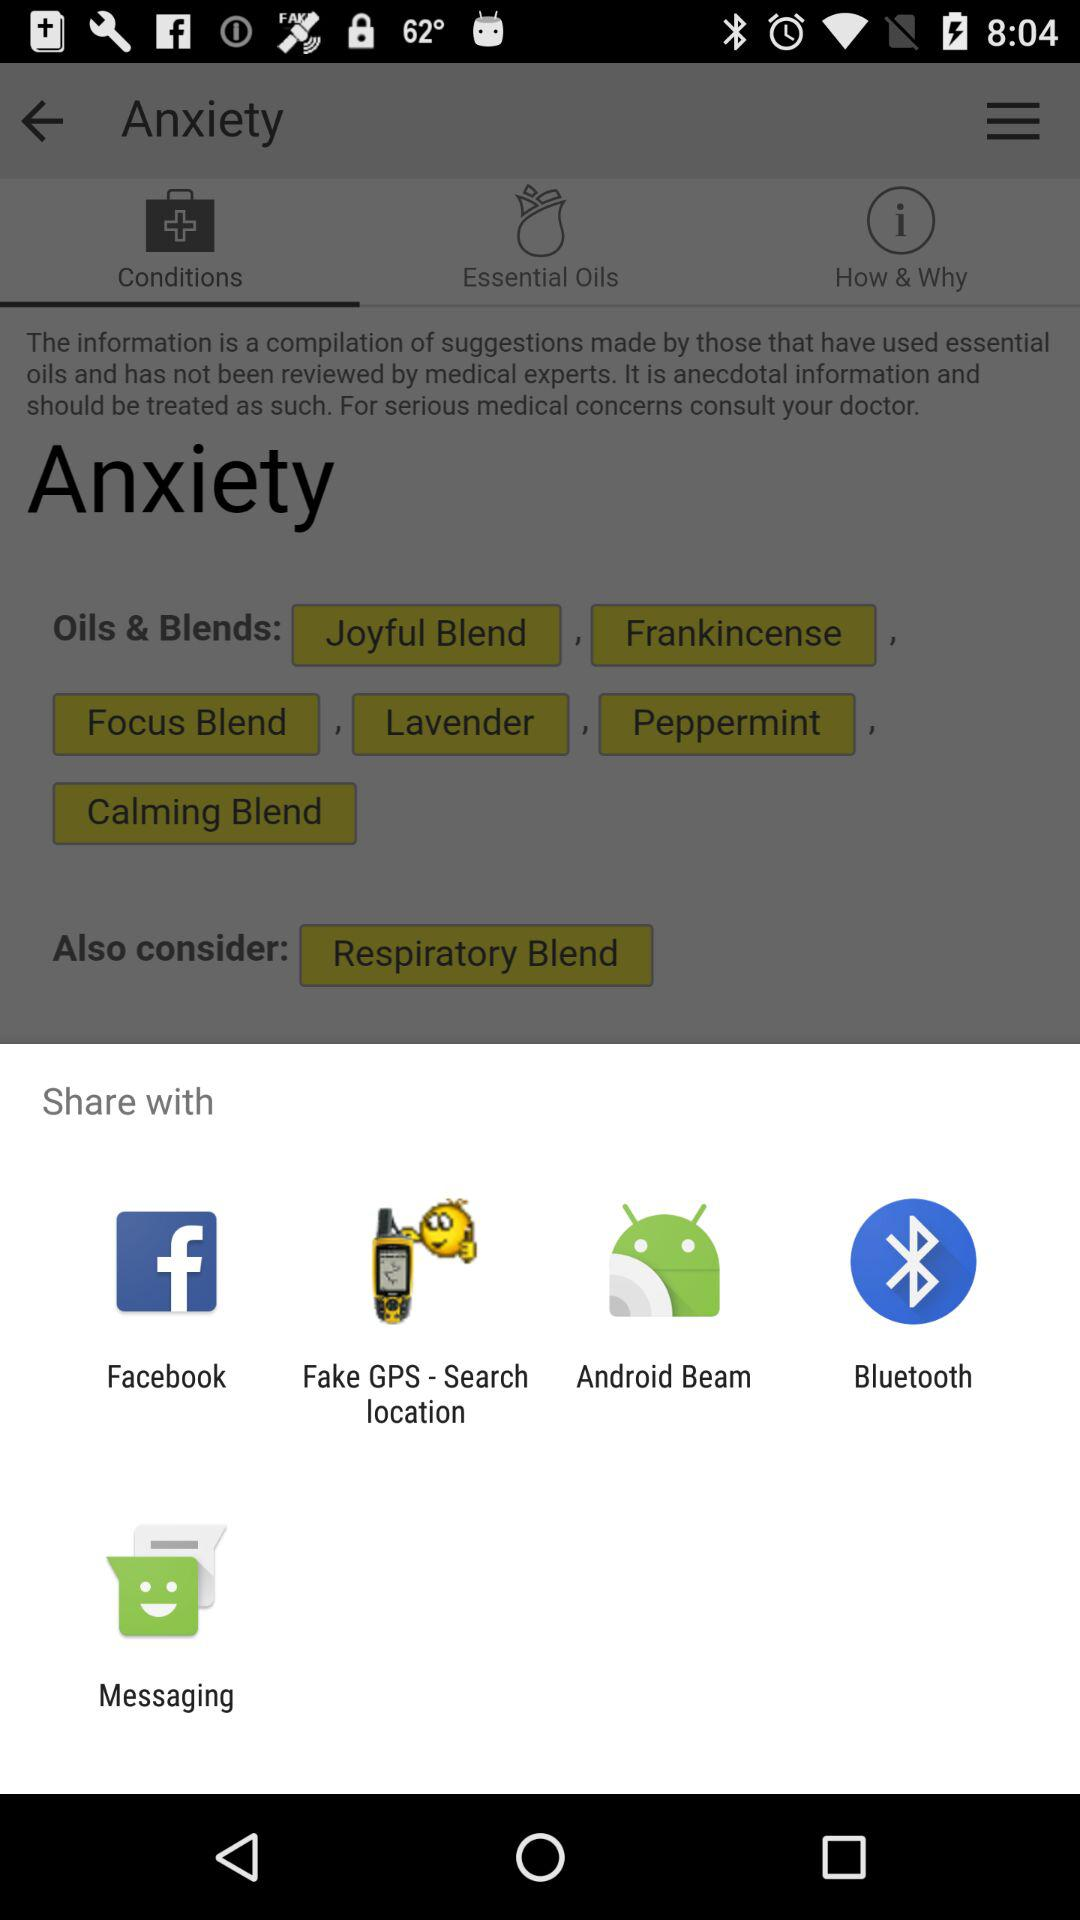Through which option can we share? You can share through "Facebook", "Fake GPS - Search location", "Android Beam", "Bluetooth" and "Messaging". 